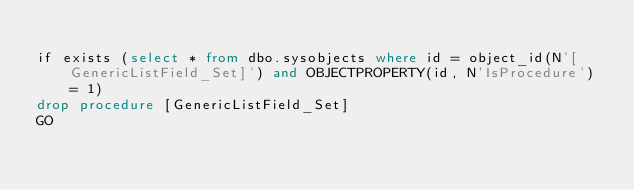Convert code to text. <code><loc_0><loc_0><loc_500><loc_500><_SQL_>
if exists (select * from dbo.sysobjects where id = object_id(N'[GenericListField_Set]') and OBJECTPROPERTY(id, N'IsProcedure') = 1)
drop procedure [GenericListField_Set]
GO


</code> 